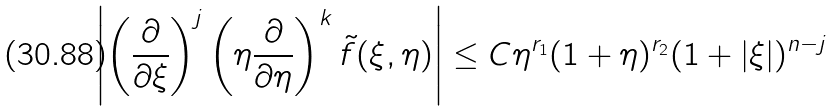<formula> <loc_0><loc_0><loc_500><loc_500>\left | \left ( \frac { \partial } { \partial \xi } \right ) ^ { j } \left ( \eta \frac { \partial } { \partial \eta } \right ) ^ { k } \tilde { f } ( \xi , \eta ) \right | \leq C \eta ^ { r _ { 1 } } ( 1 + \eta ) ^ { r _ { 2 } } ( 1 + | \xi | ) ^ { n - j }</formula> 